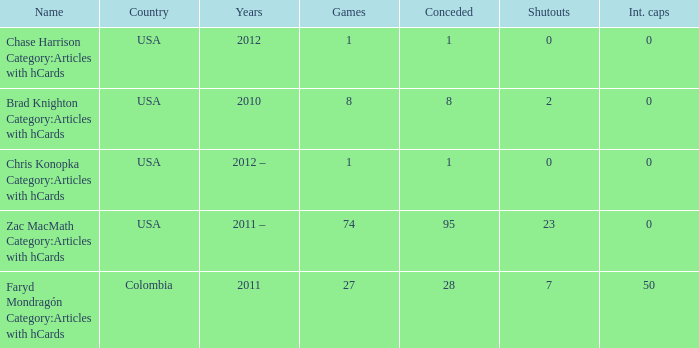When chase harrison category:articles with hcards is the name what is the year? 2012.0. 